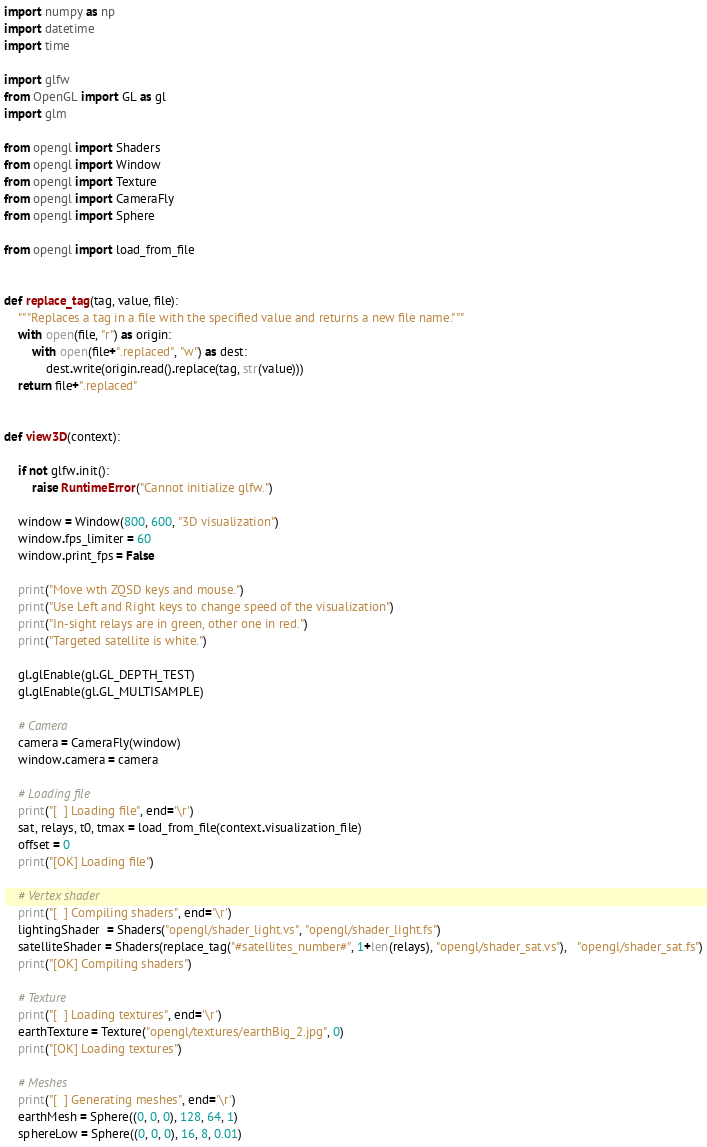Convert code to text. <code><loc_0><loc_0><loc_500><loc_500><_Python_>import numpy as np
import datetime
import time

import glfw
from OpenGL import GL as gl
import glm

from opengl import Shaders
from opengl import Window
from opengl import Texture
from opengl import CameraFly
from opengl import Sphere

from opengl import load_from_file


def replace_tag(tag, value, file):
    """Replaces a tag in a file with the specified value and returns a new file name."""
    with open(file, "r") as origin:
        with open(file+".replaced", "w") as dest:
            dest.write(origin.read().replace(tag, str(value)))
    return file+".replaced"


def view3D(context):

    if not glfw.init():
        raise RuntimeError("Cannot initialize glfw.")

    window = Window(800, 600, "3D visualization")
    window.fps_limiter = 60
    window.print_fps = False

    print("Move wth ZQSD keys and mouse.")
    print("Use Left and Right keys to change speed of the visualization")
    print("In-sight relays are in green, other one in red.")
    print("Targeted satellite is white.")

    gl.glEnable(gl.GL_DEPTH_TEST)
    gl.glEnable(gl.GL_MULTISAMPLE)

    # Camera
    camera = CameraFly(window)
    window.camera = camera

    # Loading file
    print("[  ] Loading file", end='\r')
    sat, relays, t0, tmax = load_from_file(context.visualization_file)
    offset = 0
    print("[OK] Loading file")

    # Vertex shader
    print("[  ] Compiling shaders", end='\r')
    lightingShader  = Shaders("opengl/shader_light.vs", "opengl/shader_light.fs")
    satelliteShader = Shaders(replace_tag("#satellites_number#", 1+len(relays), "opengl/shader_sat.vs"),   "opengl/shader_sat.fs")
    print("[OK] Compiling shaders")

    # Texture
    print("[  ] Loading textures", end='\r')
    earthTexture = Texture("opengl/textures/earthBig_2.jpg", 0)
    print("[OK] Loading textures")

    # Meshes
    print("[  ] Generating meshes", end='\r')
    earthMesh = Sphere((0, 0, 0), 128, 64, 1)
    sphereLow = Sphere((0, 0, 0), 16, 8, 0.01)</code> 